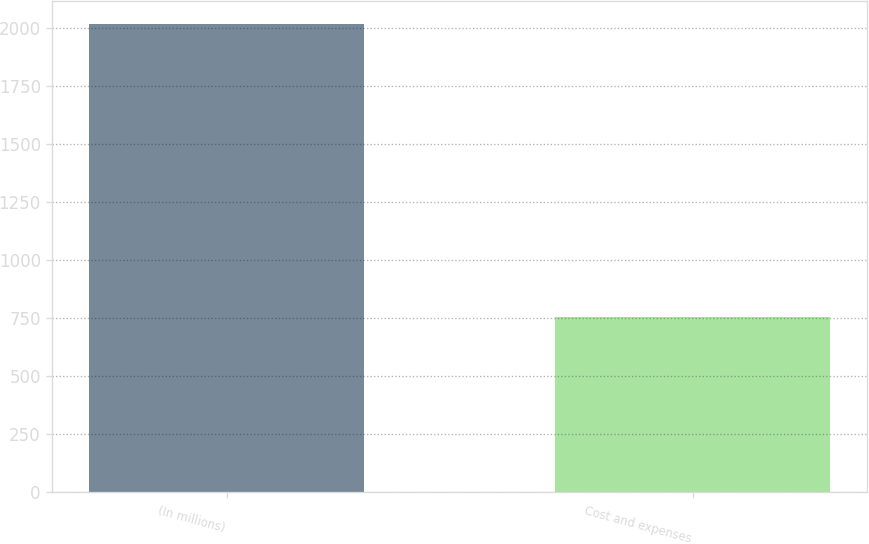Convert chart to OTSL. <chart><loc_0><loc_0><loc_500><loc_500><bar_chart><fcel>(In millions)<fcel>Cost and expenses<nl><fcel>2017<fcel>755.2<nl></chart> 